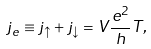Convert formula to latex. <formula><loc_0><loc_0><loc_500><loc_500>j _ { e } \equiv j _ { \uparrow } + j _ { \downarrow } = V \frac { e ^ { 2 } } { h } T ,</formula> 